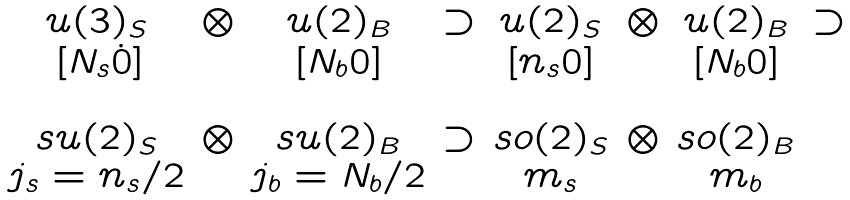<formula> <loc_0><loc_0><loc_500><loc_500>\begin{array} { c c c c c c c c } u ( 3 ) _ { S } & \otimes & u ( 2 ) _ { B } & \supset & u ( 2 ) _ { S } & \otimes & u ( 2 ) _ { B } & \supset \\ \, [ N _ { s } \dot { 0 } ] & & [ N _ { b } 0 ] & & [ n _ { s } 0 ] & & [ N _ { b } 0 ] \\ \\ s u ( 2 ) _ { S } & \otimes & s u ( 2 ) _ { B } & \supset & s o ( 2 ) _ { S } & \otimes & s o ( 2 ) _ { B } \\ j _ { s } = n _ { s } / 2 & & j _ { b } = N _ { b } / 2 & & m _ { s } & & m _ { b } \end{array}</formula> 